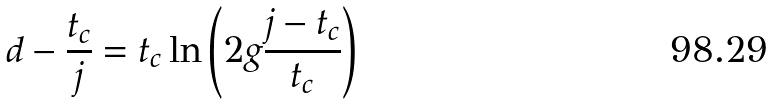<formula> <loc_0><loc_0><loc_500><loc_500>d - \frac { t _ { c } } { j } = t _ { c } \ln \left ( 2 g \frac { j - t _ { c } } { t _ { c } } \right ) \text { }</formula> 